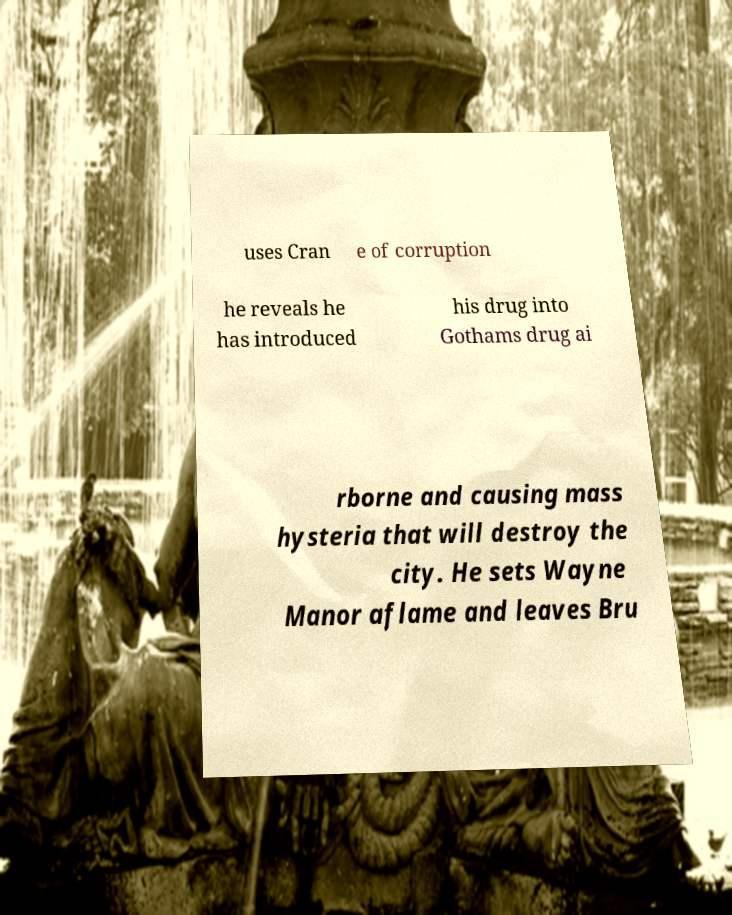What messages or text are displayed in this image? I need them in a readable, typed format. uses Cran e of corruption he reveals he has introduced his drug into Gothams drug ai rborne and causing mass hysteria that will destroy the city. He sets Wayne Manor aflame and leaves Bru 